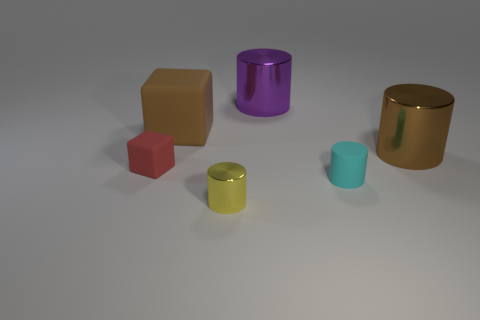Does the small cyan cylinder have the same material as the yellow thing?
Provide a short and direct response. No. What number of small things are behind the tiny metal cylinder and on the left side of the purple shiny cylinder?
Provide a succinct answer. 1. What number of other things are there of the same color as the big rubber thing?
Your answer should be compact. 1. What number of cyan things are either matte things or big shiny things?
Provide a short and direct response. 1. How big is the red rubber block?
Provide a short and direct response. Small. How many matte things are either gray spheres or blocks?
Provide a short and direct response. 2. Is the number of cubes less than the number of objects?
Ensure brevity in your answer.  Yes. How many other things are there of the same material as the large purple thing?
Provide a short and direct response. 2. What is the size of the cyan object that is the same shape as the purple metallic object?
Your response must be concise. Small. Does the large brown object left of the brown shiny thing have the same material as the tiny object to the right of the purple thing?
Your answer should be compact. Yes. 